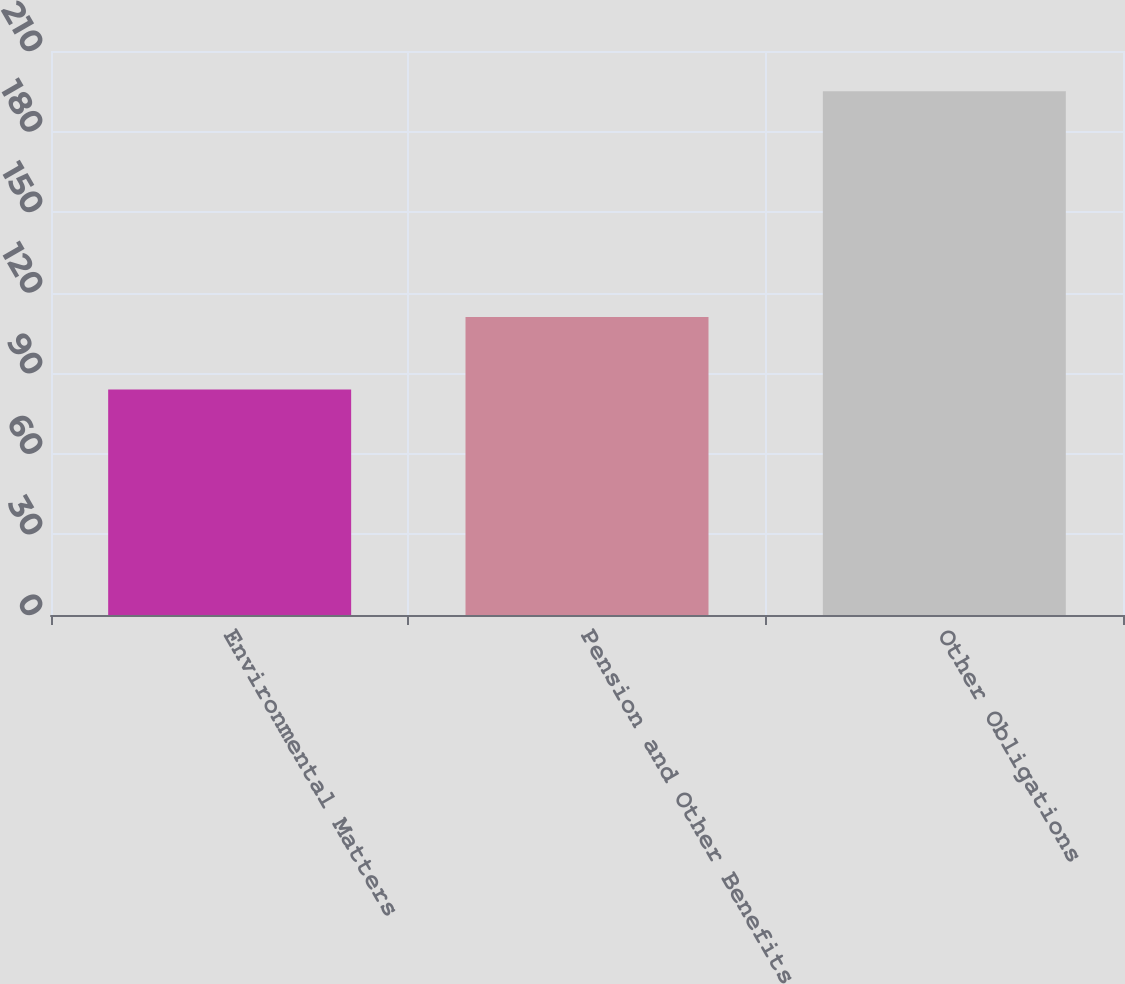Convert chart. <chart><loc_0><loc_0><loc_500><loc_500><bar_chart><fcel>Environmental Matters<fcel>Pension and Other Benefits<fcel>Other Obligations<nl><fcel>84<fcel>111<fcel>195<nl></chart> 